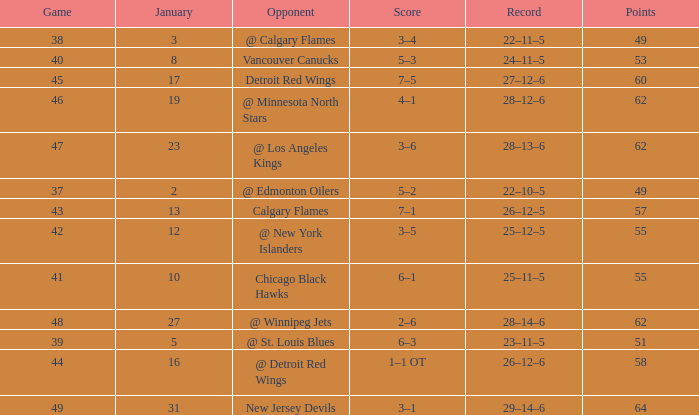Parse the table in full. {'header': ['Game', 'January', 'Opponent', 'Score', 'Record', 'Points'], 'rows': [['38', '3', '@ Calgary Flames', '3–4', '22–11–5', '49'], ['40', '8', 'Vancouver Canucks', '5–3', '24–11–5', '53'], ['45', '17', 'Detroit Red Wings', '7–5', '27–12–6', '60'], ['46', '19', '@ Minnesota North Stars', '4–1', '28–12–6', '62'], ['47', '23', '@ Los Angeles Kings', '3–6', '28–13–6', '62'], ['37', '2', '@ Edmonton Oilers', '5–2', '22–10–5', '49'], ['43', '13', 'Calgary Flames', '7–1', '26–12–5', '57'], ['42', '12', '@ New York Islanders', '3–5', '25–12–5', '55'], ['41', '10', 'Chicago Black Hawks', '6–1', '25–11–5', '55'], ['48', '27', '@ Winnipeg Jets', '2–6', '28–14–6', '62'], ['39', '5', '@ St. Louis Blues', '6–3', '23–11–5', '51'], ['44', '16', '@ Detroit Red Wings', '1–1 OT', '26–12–6', '58'], ['49', '31', 'New Jersey Devils', '3–1', '29–14–6', '64']]} How many Games have a Score of 2–6, and Points larger than 62? 0.0. 